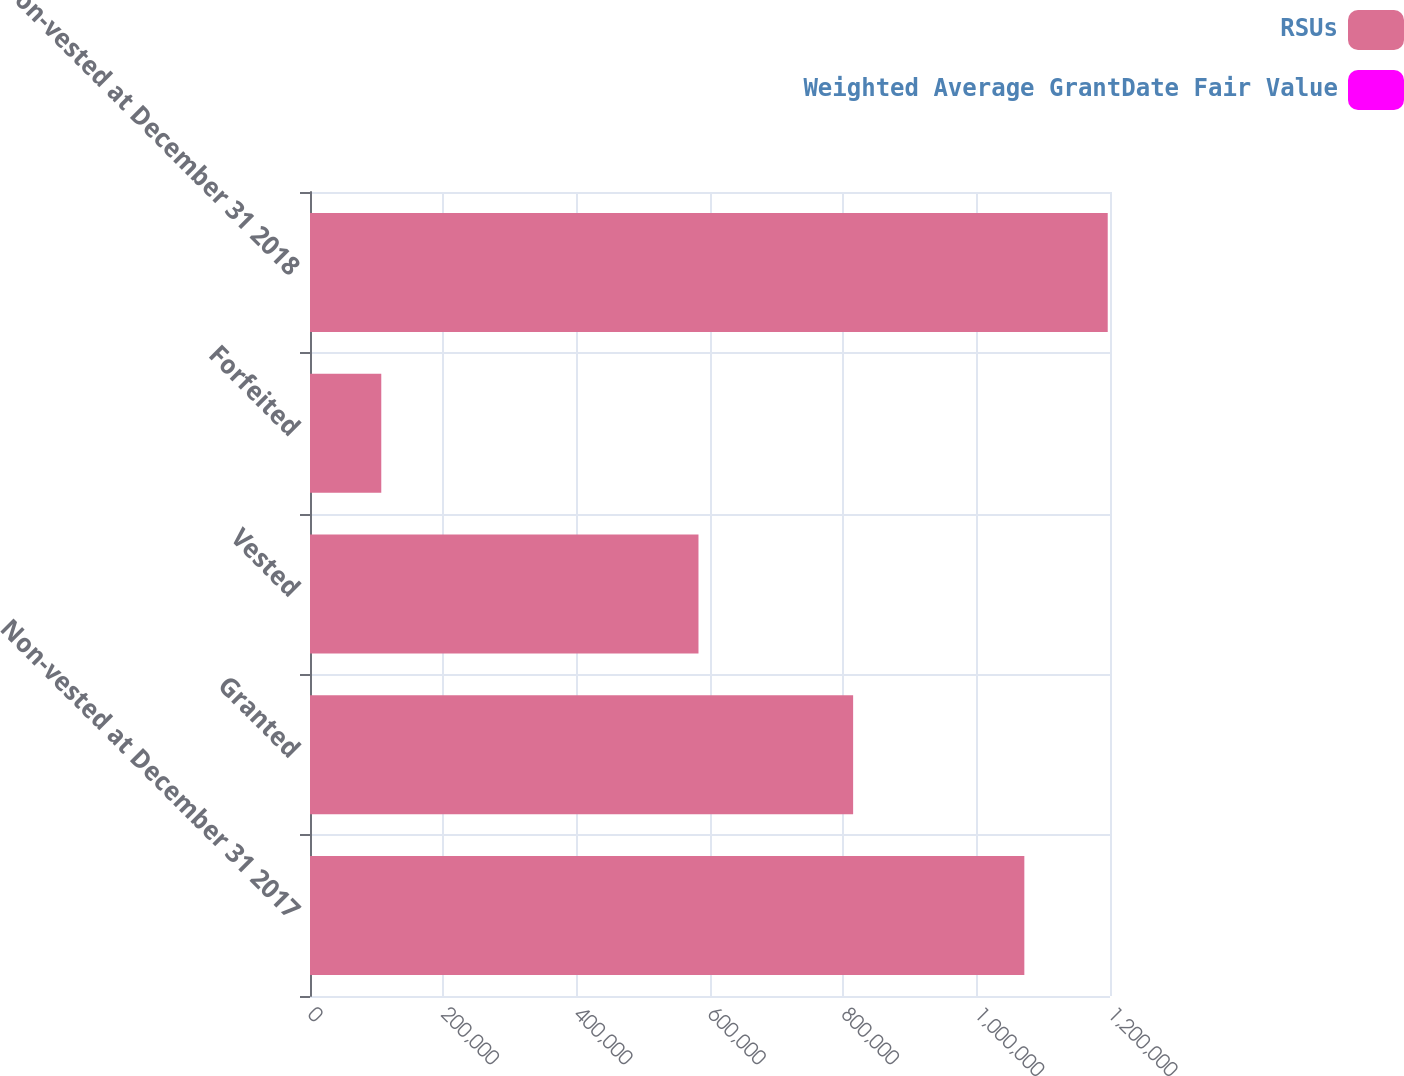Convert chart. <chart><loc_0><loc_0><loc_500><loc_500><stacked_bar_chart><ecel><fcel>Non-vested at December 31 2017<fcel>Granted<fcel>Vested<fcel>Forfeited<fcel>Non-vested at December 31 2018<nl><fcel>RSUs<fcel>1.07147e+06<fcel>814659<fcel>582687<fcel>106875<fcel>1.19657e+06<nl><fcel>Weighted Average GrantDate Fair Value<fcel>35.38<fcel>33.59<fcel>35.1<fcel>34.92<fcel>34.33<nl></chart> 